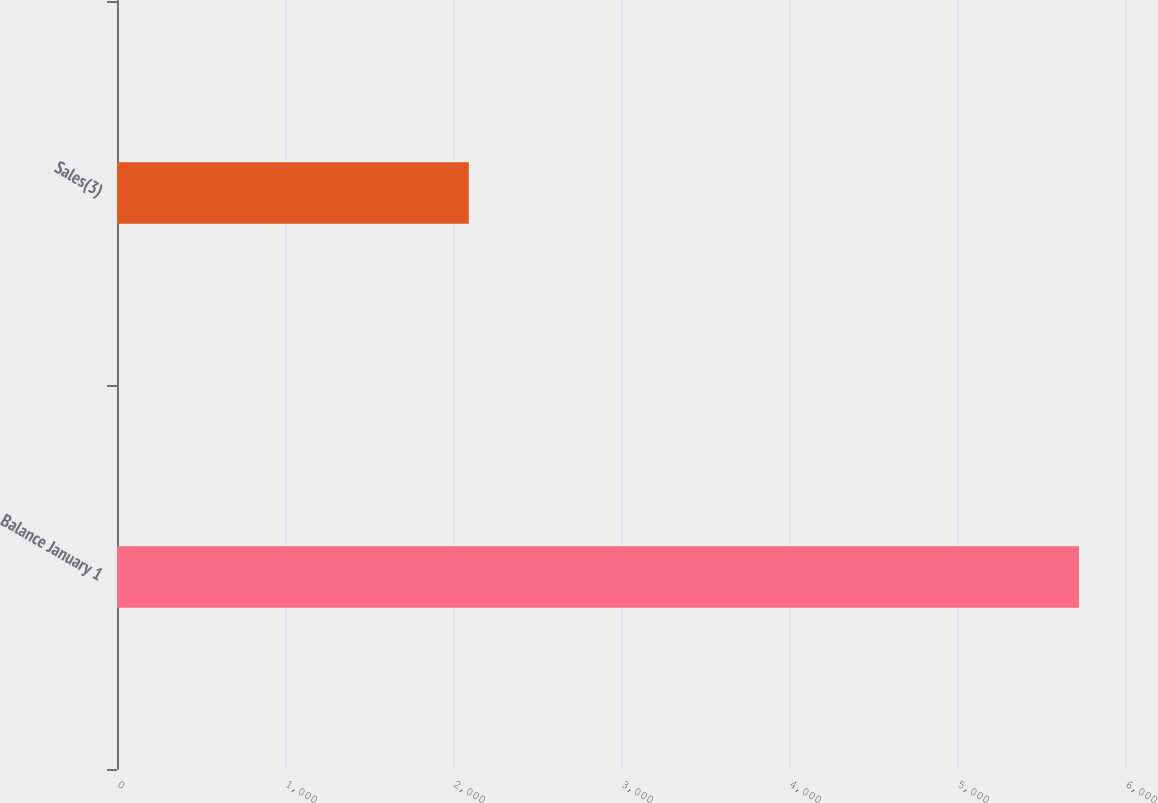Convert chart. <chart><loc_0><loc_0><loc_500><loc_500><bar_chart><fcel>Balance January 1<fcel>Sales(3)<nl><fcel>5726<fcel>2094<nl></chart> 